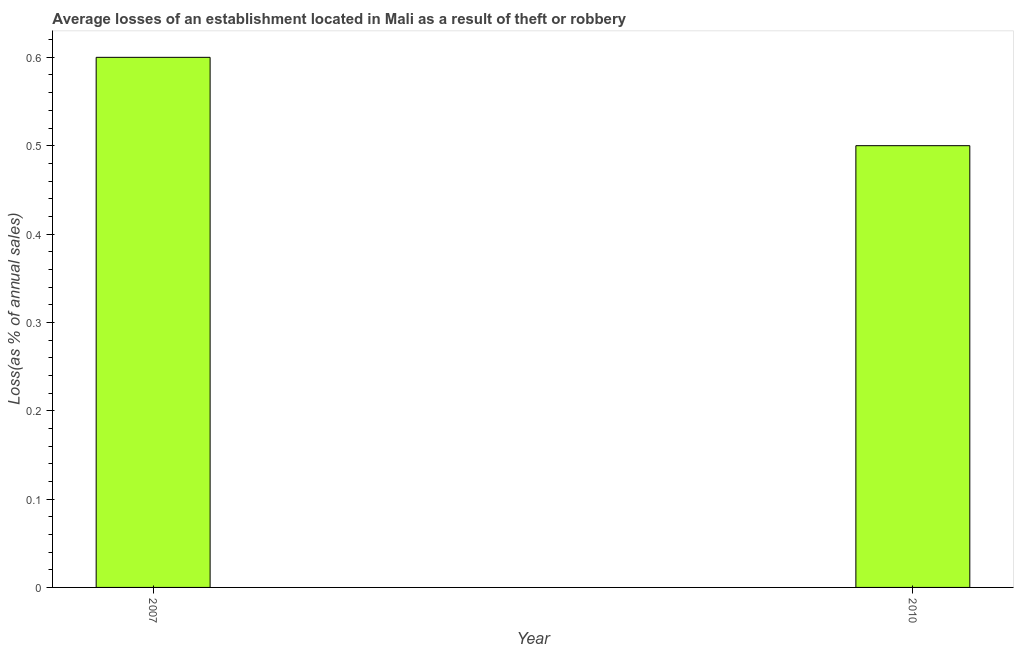What is the title of the graph?
Make the answer very short. Average losses of an establishment located in Mali as a result of theft or robbery. What is the label or title of the Y-axis?
Provide a short and direct response. Loss(as % of annual sales). Across all years, what is the maximum losses due to theft?
Offer a terse response. 0.6. Across all years, what is the minimum losses due to theft?
Offer a terse response. 0.5. In which year was the losses due to theft maximum?
Give a very brief answer. 2007. What is the sum of the losses due to theft?
Your response must be concise. 1.1. What is the average losses due to theft per year?
Provide a succinct answer. 0.55. What is the median losses due to theft?
Provide a short and direct response. 0.55. In how many years, is the losses due to theft greater than 0.1 %?
Offer a terse response. 2. Do a majority of the years between 2010 and 2007 (inclusive) have losses due to theft greater than 0.52 %?
Your response must be concise. No. What is the ratio of the losses due to theft in 2007 to that in 2010?
Your answer should be compact. 1.2. How many bars are there?
Give a very brief answer. 2. Are all the bars in the graph horizontal?
Offer a very short reply. No. What is the difference between two consecutive major ticks on the Y-axis?
Ensure brevity in your answer.  0.1. What is the ratio of the Loss(as % of annual sales) in 2007 to that in 2010?
Ensure brevity in your answer.  1.2. 